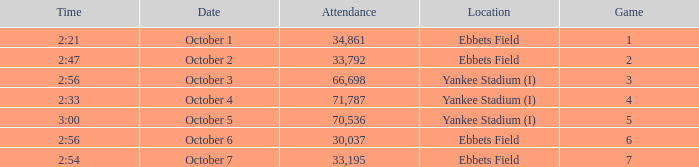Location of ebbets field, and a Time of 2:56, and a Game larger than 6 has what sum of attendance? None. 